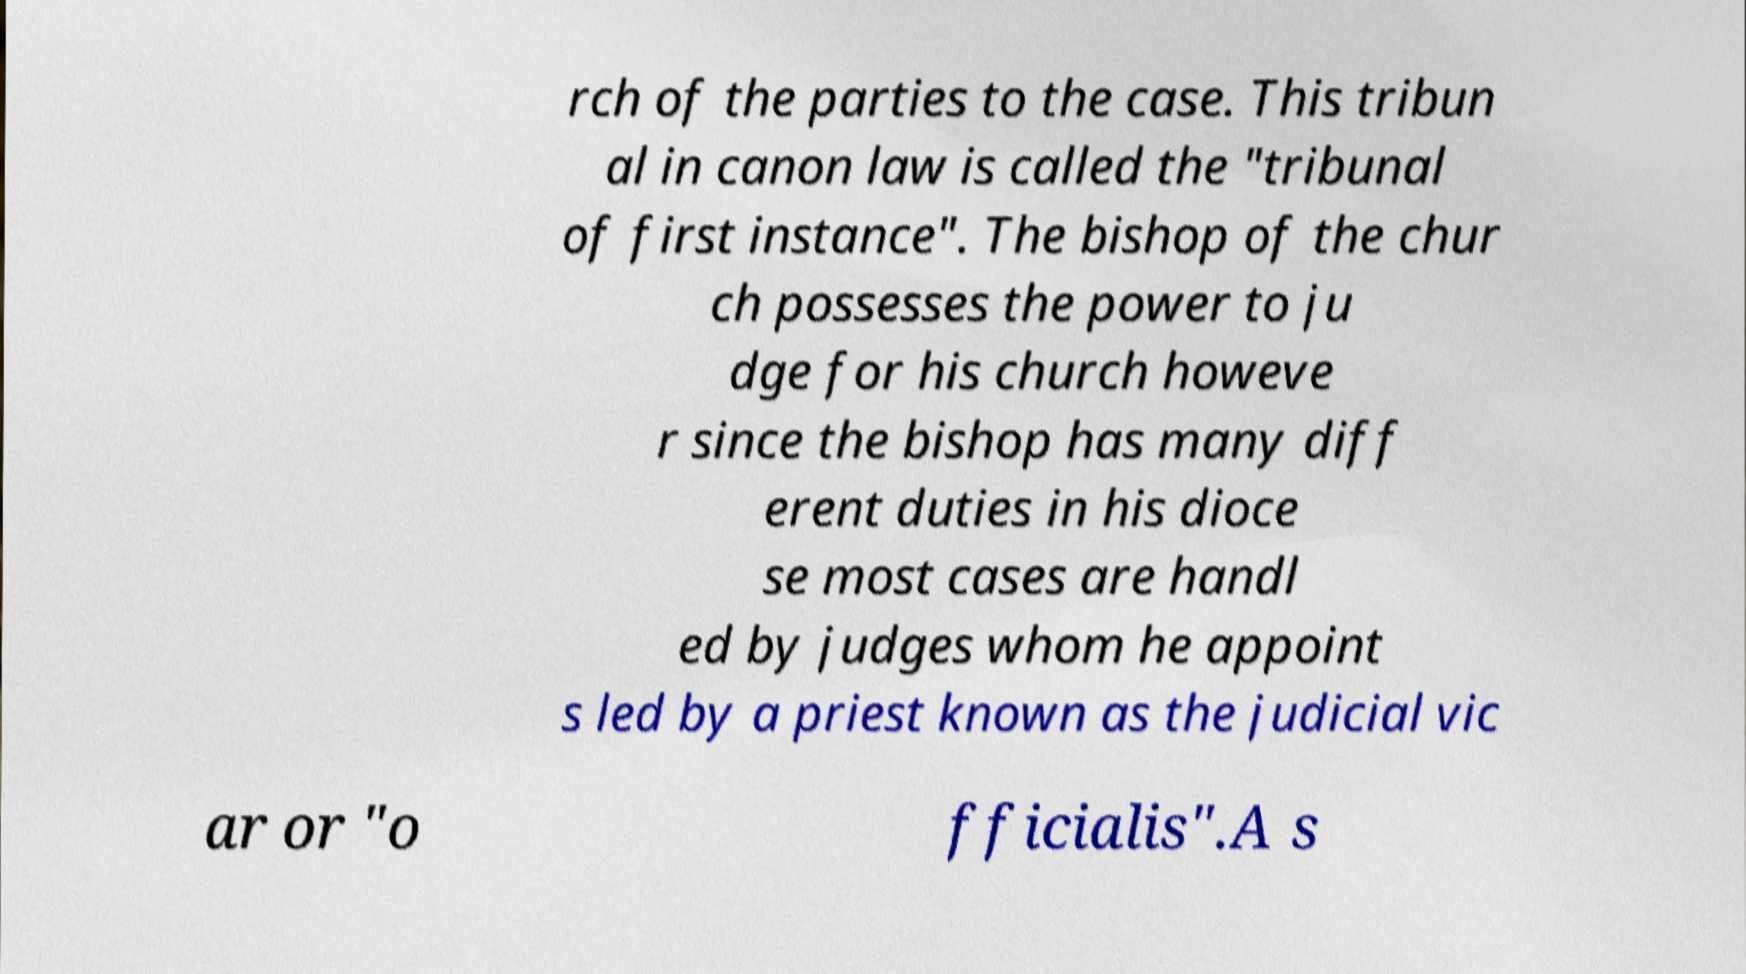I need the written content from this picture converted into text. Can you do that? rch of the parties to the case. This tribun al in canon law is called the "tribunal of first instance". The bishop of the chur ch possesses the power to ju dge for his church howeve r since the bishop has many diff erent duties in his dioce se most cases are handl ed by judges whom he appoint s led by a priest known as the judicial vic ar or "o fficialis".A s 